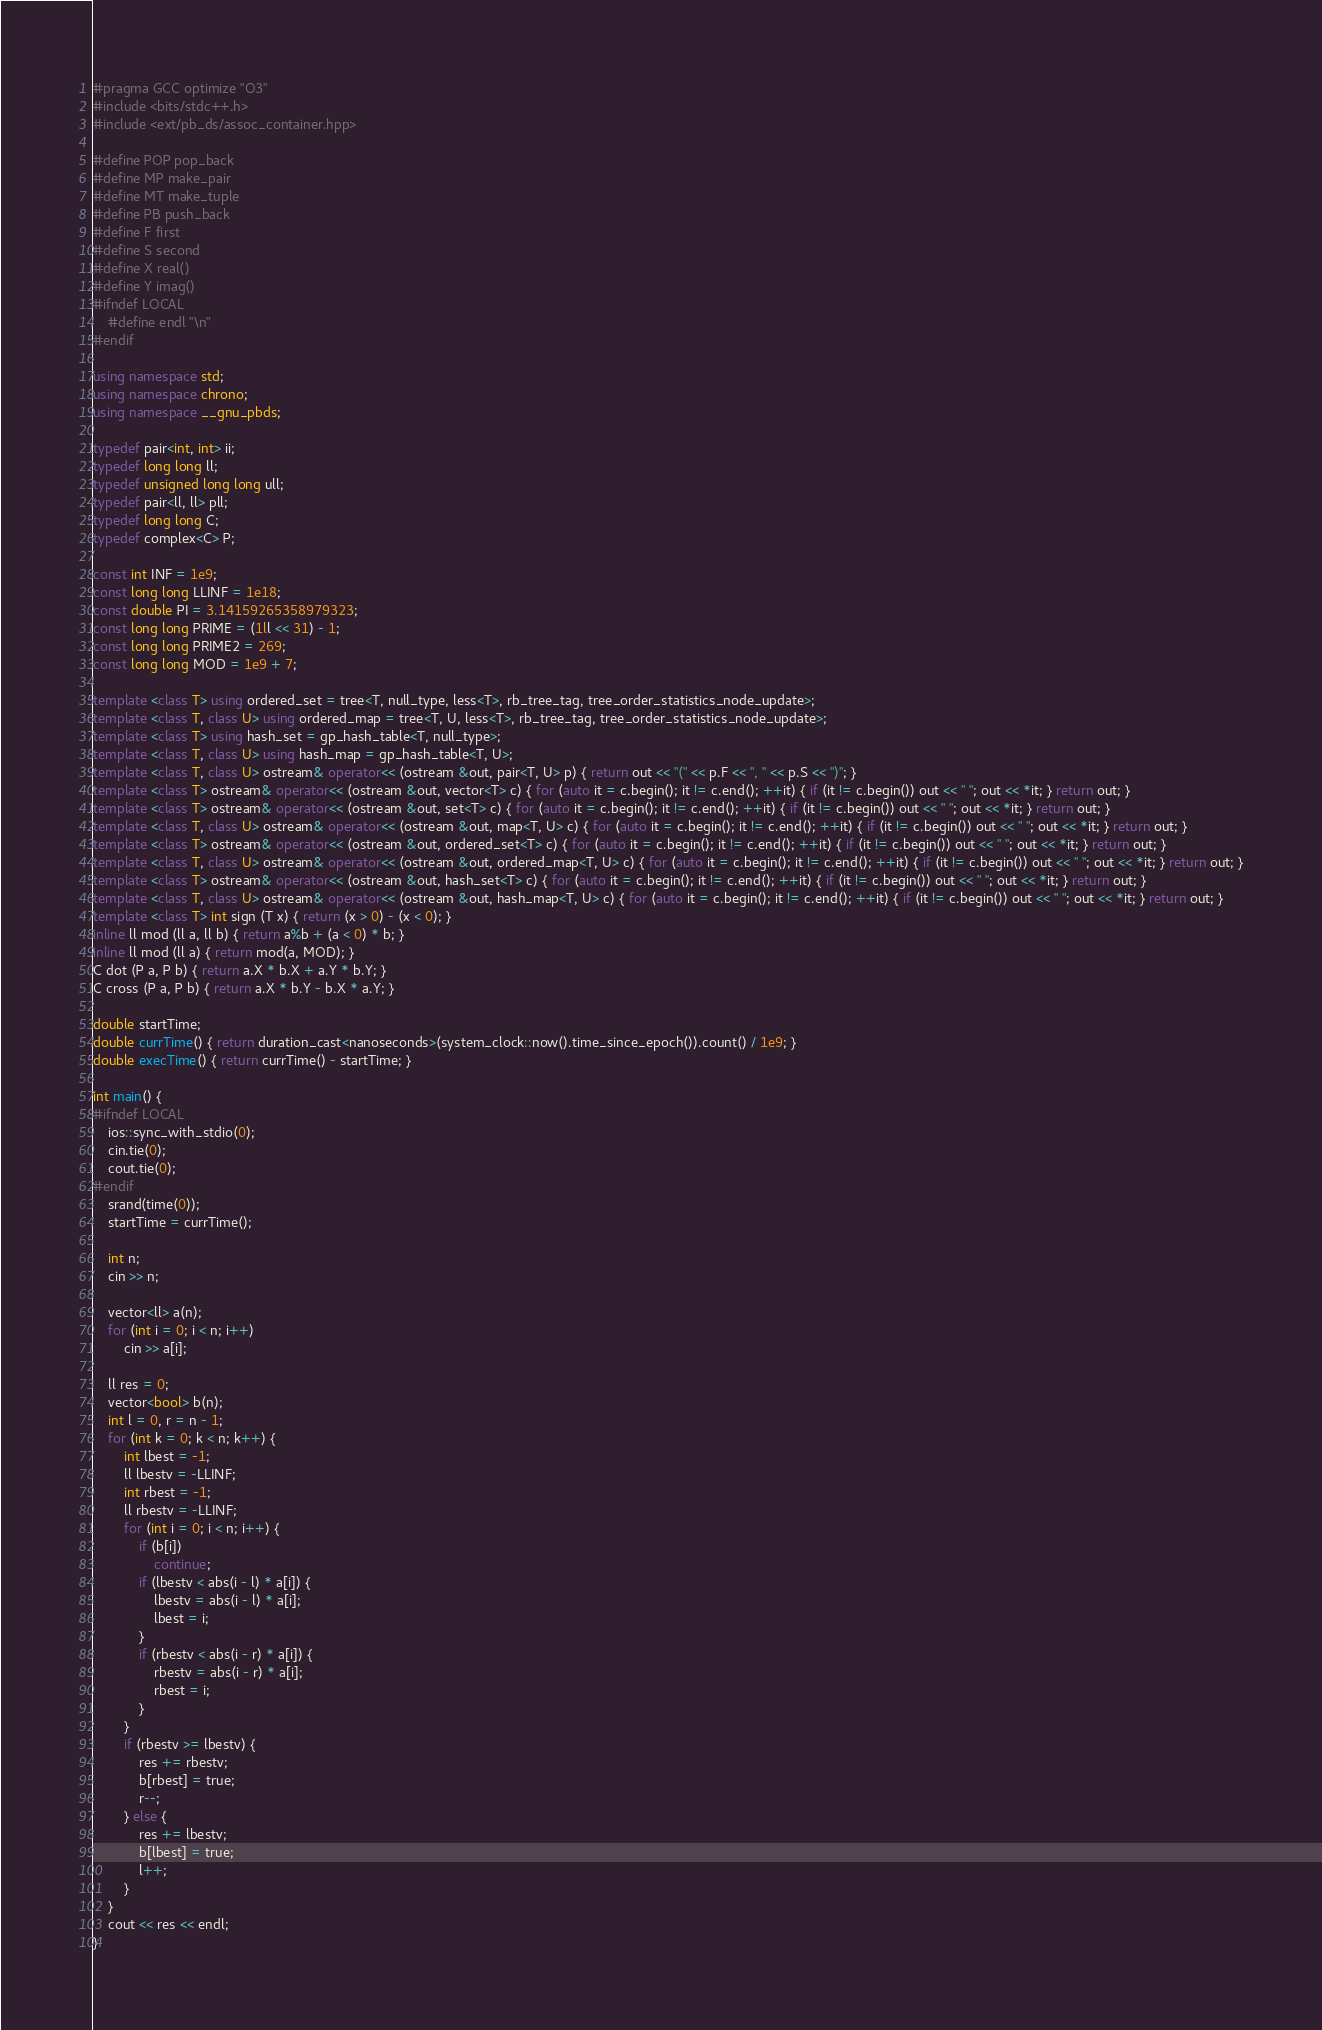Convert code to text. <code><loc_0><loc_0><loc_500><loc_500><_C++_>#pragma GCC optimize "O3"
#include <bits/stdc++.h>
#include <ext/pb_ds/assoc_container.hpp>

#define POP pop_back
#define MP make_pair
#define MT make_tuple
#define PB push_back
#define F first
#define S second
#define X real()
#define Y imag()
#ifndef LOCAL
    #define endl "\n"
#endif

using namespace std;
using namespace chrono;
using namespace __gnu_pbds;

typedef pair<int, int> ii;
typedef long long ll;
typedef unsigned long long ull;
typedef pair<ll, ll> pll;
typedef long long C;
typedef complex<C> P;

const int INF = 1e9;
const long long LLINF = 1e18;
const double PI = 3.14159265358979323;
const long long PRIME = (1ll << 31) - 1;
const long long PRIME2 = 269;
const long long MOD = 1e9 + 7;

template <class T> using ordered_set = tree<T, null_type, less<T>, rb_tree_tag, tree_order_statistics_node_update>;
template <class T, class U> using ordered_map = tree<T, U, less<T>, rb_tree_tag, tree_order_statistics_node_update>;
template <class T> using hash_set = gp_hash_table<T, null_type>;
template <class T, class U> using hash_map = gp_hash_table<T, U>;
template <class T, class U> ostream& operator<< (ostream &out, pair<T, U> p) { return out << "(" << p.F << ", " << p.S << ")"; }
template <class T> ostream& operator<< (ostream &out, vector<T> c) { for (auto it = c.begin(); it != c.end(); ++it) { if (it != c.begin()) out << " "; out << *it; } return out; }
template <class T> ostream& operator<< (ostream &out, set<T> c) { for (auto it = c.begin(); it != c.end(); ++it) { if (it != c.begin()) out << " "; out << *it; } return out; }
template <class T, class U> ostream& operator<< (ostream &out, map<T, U> c) { for (auto it = c.begin(); it != c.end(); ++it) { if (it != c.begin()) out << " "; out << *it; } return out; }
template <class T> ostream& operator<< (ostream &out, ordered_set<T> c) { for (auto it = c.begin(); it != c.end(); ++it) { if (it != c.begin()) out << " "; out << *it; } return out; }
template <class T, class U> ostream& operator<< (ostream &out, ordered_map<T, U> c) { for (auto it = c.begin(); it != c.end(); ++it) { if (it != c.begin()) out << " "; out << *it; } return out; }
template <class T> ostream& operator<< (ostream &out, hash_set<T> c) { for (auto it = c.begin(); it != c.end(); ++it) { if (it != c.begin()) out << " "; out << *it; } return out; }
template <class T, class U> ostream& operator<< (ostream &out, hash_map<T, U> c) { for (auto it = c.begin(); it != c.end(); ++it) { if (it != c.begin()) out << " "; out << *it; } return out; }
template <class T> int sign (T x) { return (x > 0) - (x < 0); }
inline ll mod (ll a, ll b) { return a%b + (a < 0) * b; }
inline ll mod (ll a) { return mod(a, MOD); }
C dot (P a, P b) { return a.X * b.X + a.Y * b.Y; }
C cross (P a, P b) { return a.X * b.Y - b.X * a.Y; }

double startTime;
double currTime() { return duration_cast<nanoseconds>(system_clock::now().time_since_epoch()).count() / 1e9; }
double execTime() { return currTime() - startTime; }

int main() {
#ifndef LOCAL
    ios::sync_with_stdio(0);
    cin.tie(0);
    cout.tie(0);
#endif
    srand(time(0));
    startTime = currTime();

    int n;
    cin >> n;

    vector<ll> a(n);
    for (int i = 0; i < n; i++)
        cin >> a[i];

    ll res = 0;
    vector<bool> b(n);
    int l = 0, r = n - 1;
    for (int k = 0; k < n; k++) {
        int lbest = -1;
        ll lbestv = -LLINF;
        int rbest = -1;
        ll rbestv = -LLINF;
        for (int i = 0; i < n; i++) {
            if (b[i])
                continue;
            if (lbestv < abs(i - l) * a[i]) {
                lbestv = abs(i - l) * a[i];
                lbest = i;
            }
            if (rbestv < abs(i - r) * a[i]) {
                rbestv = abs(i - r) * a[i];
                rbest = i;
            }
        }
        if (rbestv >= lbestv) {
            res += rbestv;
            b[rbest] = true;
            r--;
        } else {
            res += lbestv;
            b[lbest] = true;
            l++;
        }
    }
    cout << res << endl;
}</code> 